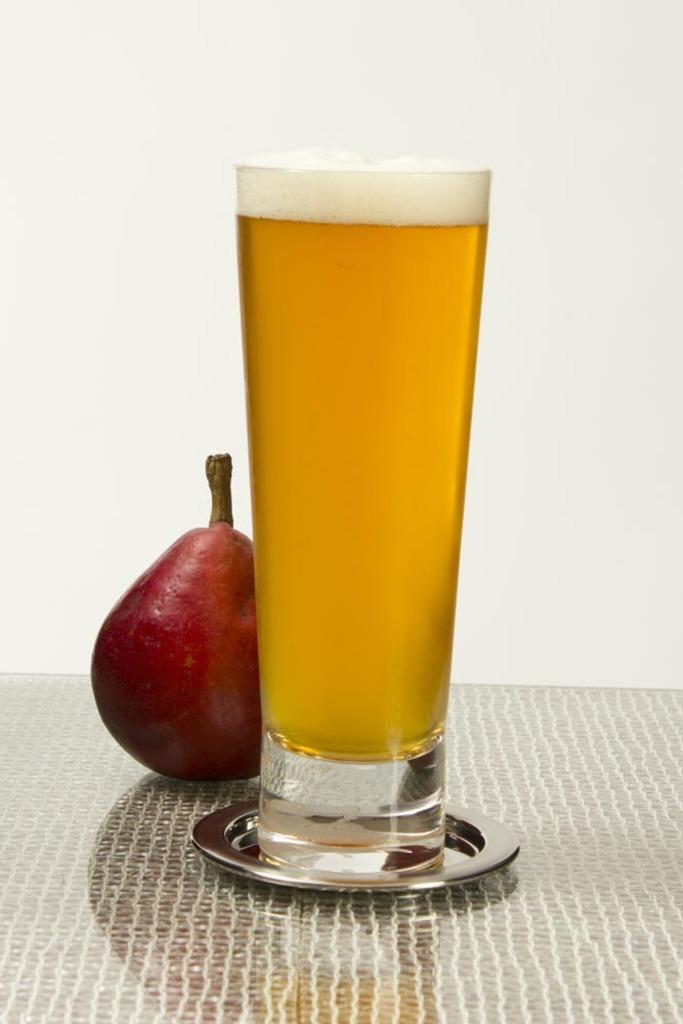What type of food is present in the image? There is a fruit in the image. What else can be seen on the table in the image? There is a glass with liquid on the table in the image. Where is the fruit and glass located? Both the fruit and the glass are on a table. What can be seen in the background of the image? There is a wall visible in the background of the image. What type of throne is depicted in the image? There is no throne present in the image. Can you describe the heart-shaped design on the fruit in the image? The fruit in the image does not have a heart-shaped design; it is a regular fruit. 